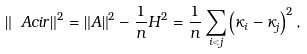<formula> <loc_0><loc_0><loc_500><loc_500>\left \| \ A c i r \right \| ^ { 2 } = \left \| A \right \| ^ { 2 } - \frac { 1 } { n } H ^ { 2 } = \frac { 1 } { n } \sum _ { i < j } \left ( \kappa _ { i } - \kappa _ { j } \right ) ^ { 2 } ,</formula> 